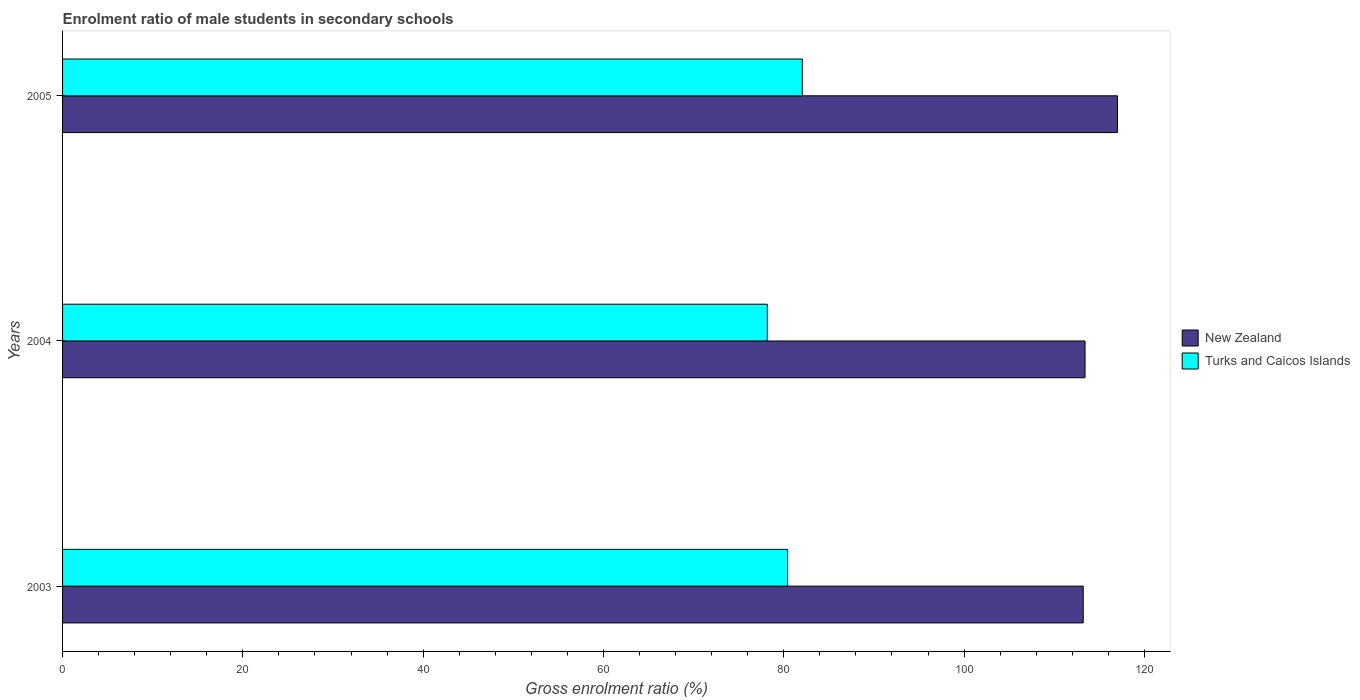How many groups of bars are there?
Provide a succinct answer. 3. Are the number of bars per tick equal to the number of legend labels?
Your answer should be very brief. Yes. What is the label of the 2nd group of bars from the top?
Provide a succinct answer. 2004. In how many cases, is the number of bars for a given year not equal to the number of legend labels?
Ensure brevity in your answer.  0. What is the enrolment ratio of male students in secondary schools in Turks and Caicos Islands in 2005?
Ensure brevity in your answer.  82.06. Across all years, what is the maximum enrolment ratio of male students in secondary schools in New Zealand?
Provide a short and direct response. 117.01. Across all years, what is the minimum enrolment ratio of male students in secondary schools in New Zealand?
Offer a terse response. 113.22. In which year was the enrolment ratio of male students in secondary schools in Turks and Caicos Islands minimum?
Offer a terse response. 2004. What is the total enrolment ratio of male students in secondary schools in New Zealand in the graph?
Offer a terse response. 343.64. What is the difference between the enrolment ratio of male students in secondary schools in New Zealand in 2003 and that in 2005?
Your answer should be very brief. -3.8. What is the difference between the enrolment ratio of male students in secondary schools in Turks and Caicos Islands in 2004 and the enrolment ratio of male students in secondary schools in New Zealand in 2003?
Your answer should be compact. -35.05. What is the average enrolment ratio of male students in secondary schools in New Zealand per year?
Your answer should be very brief. 114.55. In the year 2005, what is the difference between the enrolment ratio of male students in secondary schools in Turks and Caicos Islands and enrolment ratio of male students in secondary schools in New Zealand?
Your response must be concise. -34.95. In how many years, is the enrolment ratio of male students in secondary schools in New Zealand greater than 116 %?
Offer a terse response. 1. What is the ratio of the enrolment ratio of male students in secondary schools in New Zealand in 2003 to that in 2005?
Your response must be concise. 0.97. Is the enrolment ratio of male students in secondary schools in New Zealand in 2003 less than that in 2004?
Keep it short and to the point. Yes. What is the difference between the highest and the second highest enrolment ratio of male students in secondary schools in New Zealand?
Your answer should be very brief. 3.59. What is the difference between the highest and the lowest enrolment ratio of male students in secondary schools in New Zealand?
Your answer should be compact. 3.8. What does the 1st bar from the top in 2005 represents?
Offer a very short reply. Turks and Caicos Islands. What does the 1st bar from the bottom in 2004 represents?
Ensure brevity in your answer.  New Zealand. Are all the bars in the graph horizontal?
Your answer should be compact. Yes. What is the difference between two consecutive major ticks on the X-axis?
Give a very brief answer. 20. Are the values on the major ticks of X-axis written in scientific E-notation?
Your answer should be very brief. No. Does the graph contain grids?
Offer a very short reply. No. How many legend labels are there?
Your answer should be compact. 2. What is the title of the graph?
Offer a terse response. Enrolment ratio of male students in secondary schools. What is the label or title of the Y-axis?
Ensure brevity in your answer.  Years. What is the Gross enrolment ratio (%) in New Zealand in 2003?
Provide a succinct answer. 113.22. What is the Gross enrolment ratio (%) in Turks and Caicos Islands in 2003?
Make the answer very short. 80.42. What is the Gross enrolment ratio (%) of New Zealand in 2004?
Your answer should be compact. 113.42. What is the Gross enrolment ratio (%) of Turks and Caicos Islands in 2004?
Your response must be concise. 78.17. What is the Gross enrolment ratio (%) in New Zealand in 2005?
Ensure brevity in your answer.  117.01. What is the Gross enrolment ratio (%) in Turks and Caicos Islands in 2005?
Keep it short and to the point. 82.06. Across all years, what is the maximum Gross enrolment ratio (%) in New Zealand?
Make the answer very short. 117.01. Across all years, what is the maximum Gross enrolment ratio (%) of Turks and Caicos Islands?
Offer a very short reply. 82.06. Across all years, what is the minimum Gross enrolment ratio (%) of New Zealand?
Provide a succinct answer. 113.22. Across all years, what is the minimum Gross enrolment ratio (%) in Turks and Caicos Islands?
Provide a short and direct response. 78.17. What is the total Gross enrolment ratio (%) of New Zealand in the graph?
Provide a short and direct response. 343.64. What is the total Gross enrolment ratio (%) of Turks and Caicos Islands in the graph?
Give a very brief answer. 240.65. What is the difference between the Gross enrolment ratio (%) in New Zealand in 2003 and that in 2004?
Offer a terse response. -0.2. What is the difference between the Gross enrolment ratio (%) of Turks and Caicos Islands in 2003 and that in 2004?
Ensure brevity in your answer.  2.25. What is the difference between the Gross enrolment ratio (%) in New Zealand in 2003 and that in 2005?
Offer a very short reply. -3.8. What is the difference between the Gross enrolment ratio (%) of Turks and Caicos Islands in 2003 and that in 2005?
Your answer should be compact. -1.63. What is the difference between the Gross enrolment ratio (%) in New Zealand in 2004 and that in 2005?
Your answer should be compact. -3.59. What is the difference between the Gross enrolment ratio (%) of Turks and Caicos Islands in 2004 and that in 2005?
Your answer should be very brief. -3.89. What is the difference between the Gross enrolment ratio (%) of New Zealand in 2003 and the Gross enrolment ratio (%) of Turks and Caicos Islands in 2004?
Your answer should be compact. 35.05. What is the difference between the Gross enrolment ratio (%) in New Zealand in 2003 and the Gross enrolment ratio (%) in Turks and Caicos Islands in 2005?
Your answer should be compact. 31.16. What is the difference between the Gross enrolment ratio (%) in New Zealand in 2004 and the Gross enrolment ratio (%) in Turks and Caicos Islands in 2005?
Ensure brevity in your answer.  31.36. What is the average Gross enrolment ratio (%) in New Zealand per year?
Offer a very short reply. 114.55. What is the average Gross enrolment ratio (%) in Turks and Caicos Islands per year?
Provide a short and direct response. 80.22. In the year 2003, what is the difference between the Gross enrolment ratio (%) in New Zealand and Gross enrolment ratio (%) in Turks and Caicos Islands?
Keep it short and to the point. 32.79. In the year 2004, what is the difference between the Gross enrolment ratio (%) of New Zealand and Gross enrolment ratio (%) of Turks and Caicos Islands?
Offer a terse response. 35.25. In the year 2005, what is the difference between the Gross enrolment ratio (%) in New Zealand and Gross enrolment ratio (%) in Turks and Caicos Islands?
Make the answer very short. 34.95. What is the ratio of the Gross enrolment ratio (%) of Turks and Caicos Islands in 2003 to that in 2004?
Your answer should be very brief. 1.03. What is the ratio of the Gross enrolment ratio (%) of New Zealand in 2003 to that in 2005?
Ensure brevity in your answer.  0.97. What is the ratio of the Gross enrolment ratio (%) in Turks and Caicos Islands in 2003 to that in 2005?
Your answer should be compact. 0.98. What is the ratio of the Gross enrolment ratio (%) in New Zealand in 2004 to that in 2005?
Keep it short and to the point. 0.97. What is the ratio of the Gross enrolment ratio (%) in Turks and Caicos Islands in 2004 to that in 2005?
Give a very brief answer. 0.95. What is the difference between the highest and the second highest Gross enrolment ratio (%) of New Zealand?
Make the answer very short. 3.59. What is the difference between the highest and the second highest Gross enrolment ratio (%) in Turks and Caicos Islands?
Offer a terse response. 1.63. What is the difference between the highest and the lowest Gross enrolment ratio (%) in New Zealand?
Give a very brief answer. 3.8. What is the difference between the highest and the lowest Gross enrolment ratio (%) of Turks and Caicos Islands?
Your response must be concise. 3.89. 